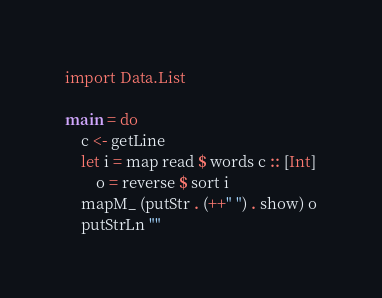Convert code to text. <code><loc_0><loc_0><loc_500><loc_500><_Haskell_>import Data.List

main = do
    c <- getLine
    let i = map read $ words c :: [Int]
        o = reverse $ sort i
    mapM_ (putStr . (++" ") . show) o
    putStrLn ""</code> 